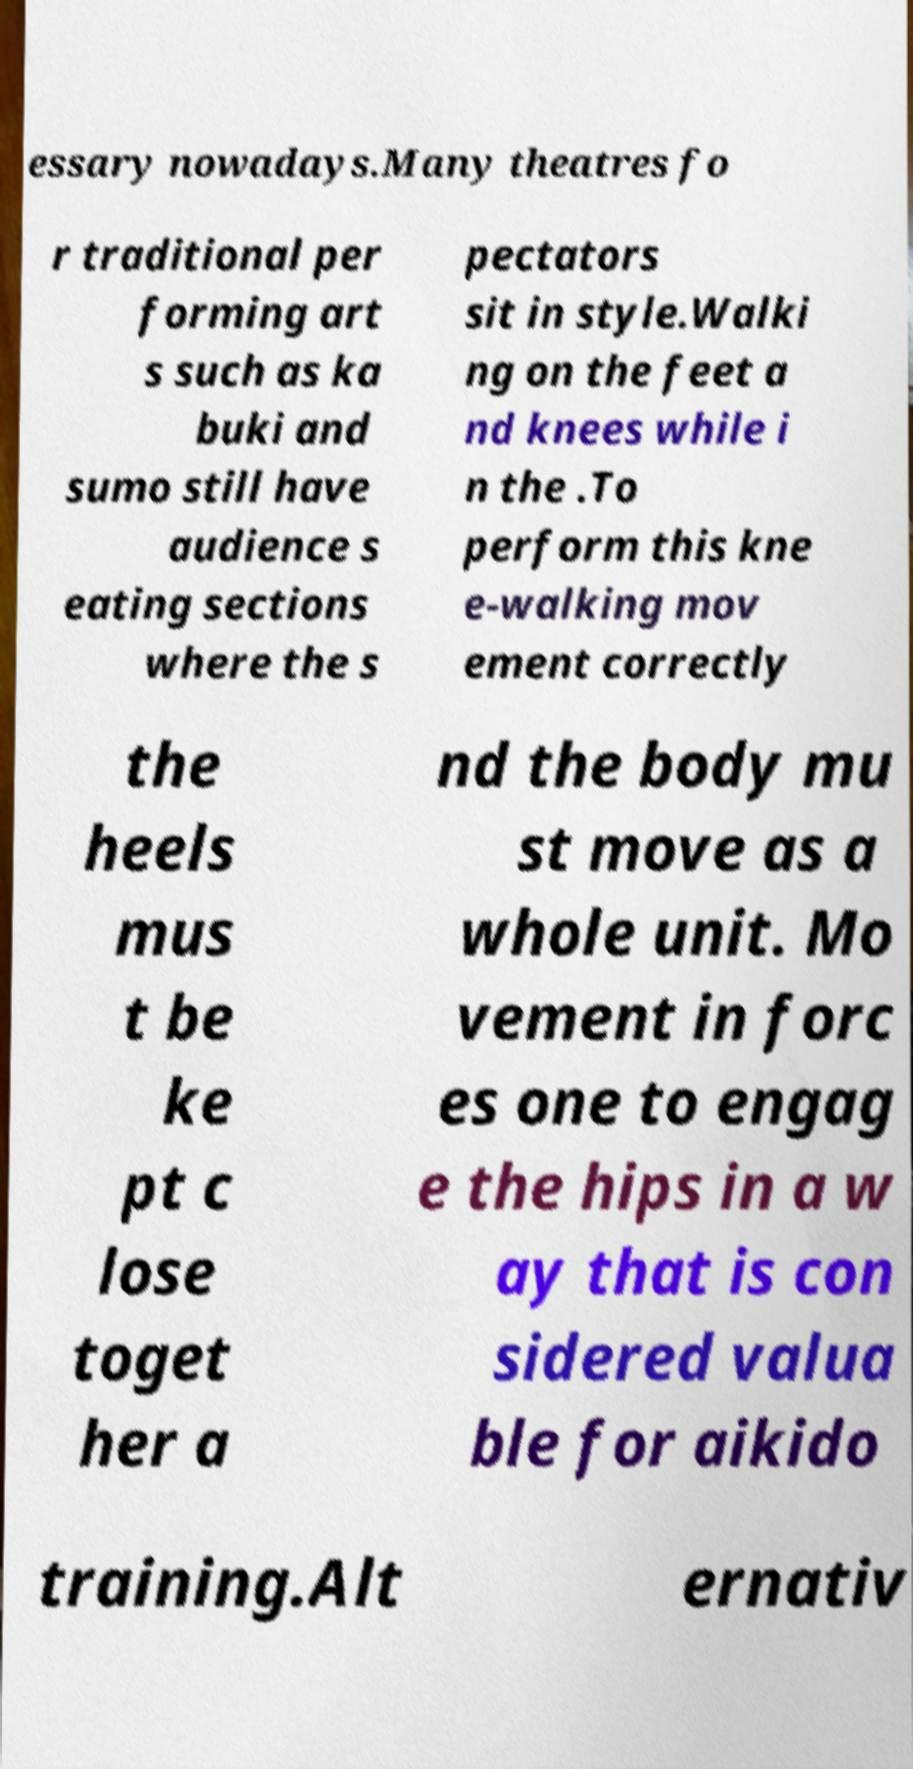For documentation purposes, I need the text within this image transcribed. Could you provide that? essary nowadays.Many theatres fo r traditional per forming art s such as ka buki and sumo still have audience s eating sections where the s pectators sit in style.Walki ng on the feet a nd knees while i n the .To perform this kne e-walking mov ement correctly the heels mus t be ke pt c lose toget her a nd the body mu st move as a whole unit. Mo vement in forc es one to engag e the hips in a w ay that is con sidered valua ble for aikido training.Alt ernativ 